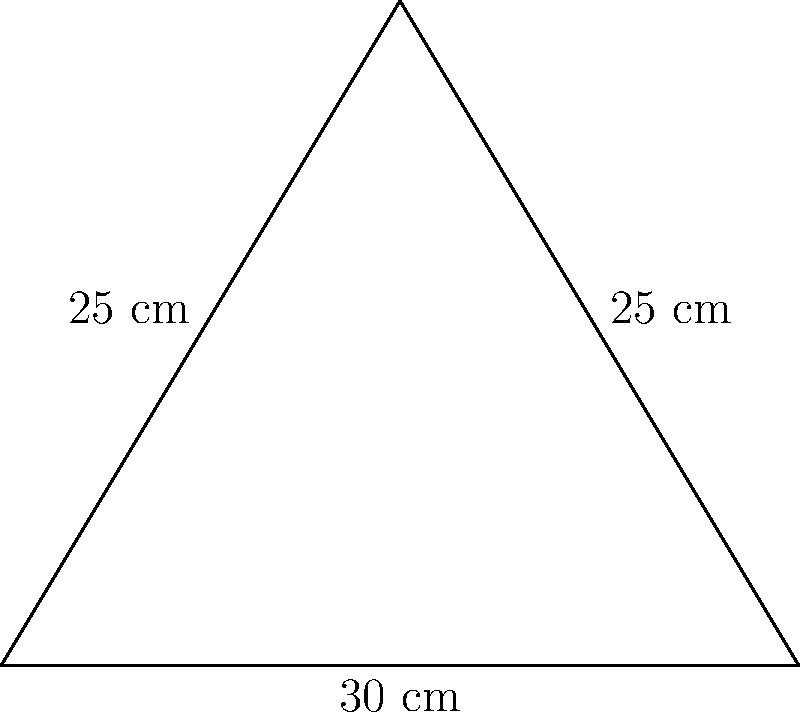As a safety-conscious factory worker, you're tasked with creating a triangular caution sign for a slippery floor area. The sign has a base of 30 cm and equal sides of 25 cm each. Calculate the area of this triangular sign to ensure it's visible enough for your coworkers. To find the area of the triangular sign, we'll use Heron's formula. Let's approach this step-by-step:

1) First, recall Heron's formula: 
   $$A = \sqrt{s(s-a)(s-b)(s-c)}$$
   where $A$ is the area, $s$ is the semi-perimeter, and $a$, $b$, and $c$ are the side lengths.

2) We know the side lengths:
   $a = 30$ cm (base)
   $b = 25$ cm
   $c = 25$ cm

3) Calculate the semi-perimeter $s$:
   $$s = \frac{a + b + c}{2} = \frac{30 + 25 + 25}{2} = \frac{80}{2} = 40$$ cm

4) Now, let's substitute these values into Heron's formula:
   $$A = \sqrt{40(40-30)(40-25)(40-25)}$$
   $$A = \sqrt{40 \cdot 10 \cdot 15 \cdot 15}$$
   $$A = \sqrt{90000}$$
   $$A = 300$$ sq cm

Therefore, the area of the triangular caution sign is 300 square centimeters.
Answer: 300 sq cm 